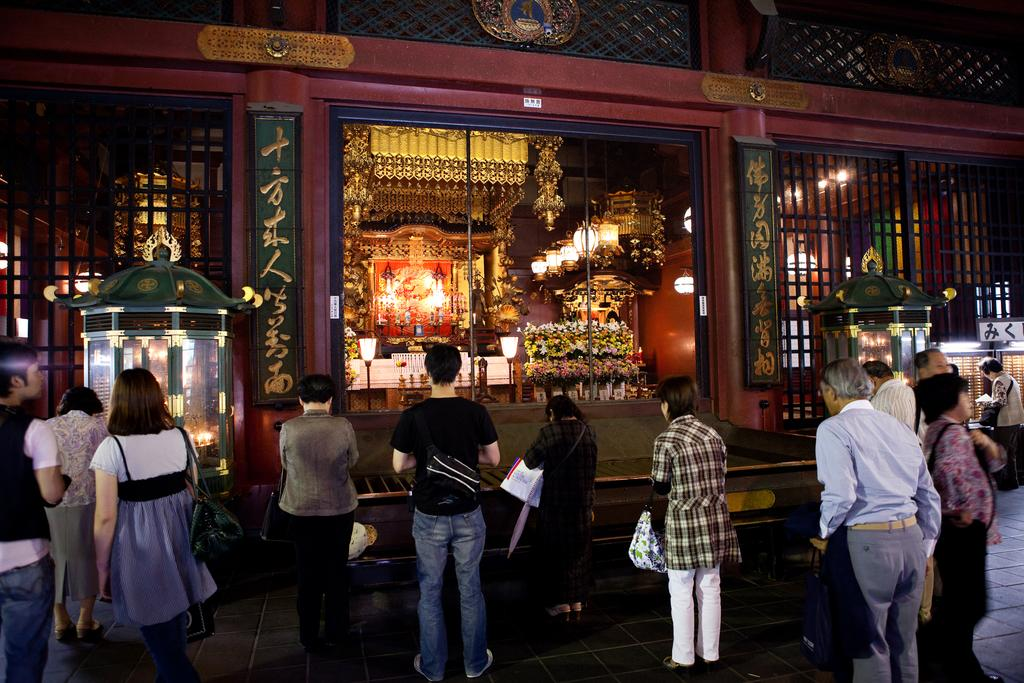What are the people in the image doing? The people in the image are standing on the road and praying. What can be seen in the background of the image? There are lights, lamps, a wooden wall, and a house in the background. What is the governor doing in the image? There is no governor present in the image. How does the stomach of the person in the image feel? There is no information about the person's stomach in the image. 